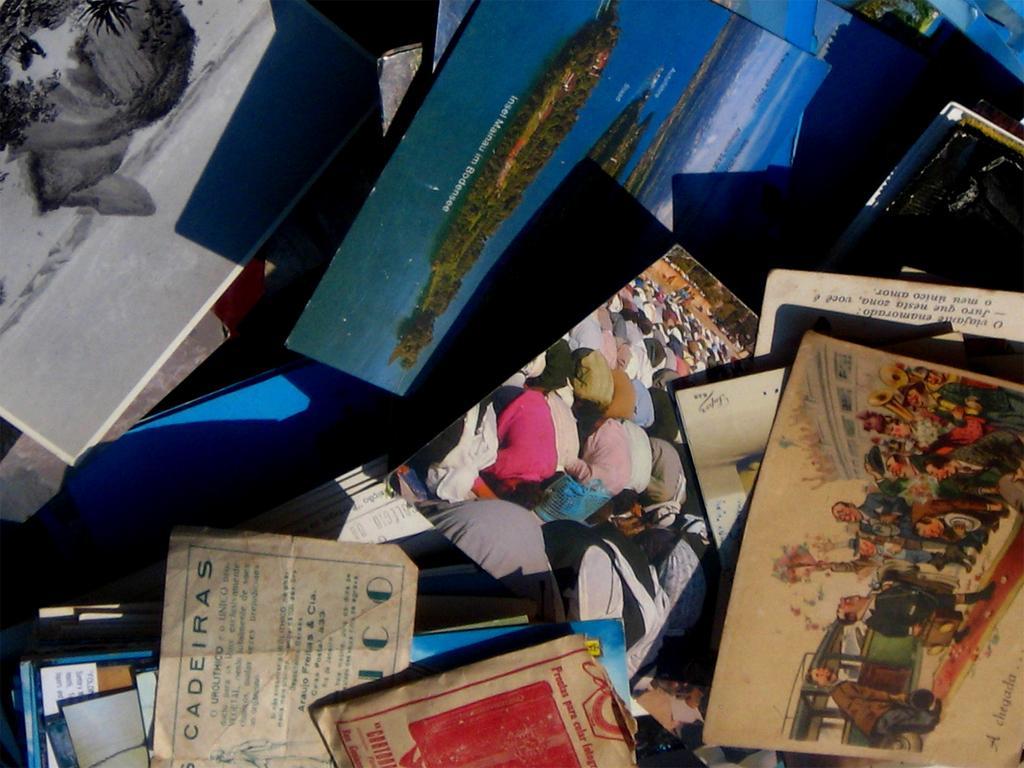In one or two sentences, can you explain what this image depicts? In the image we can see there are photos, papers and books. 